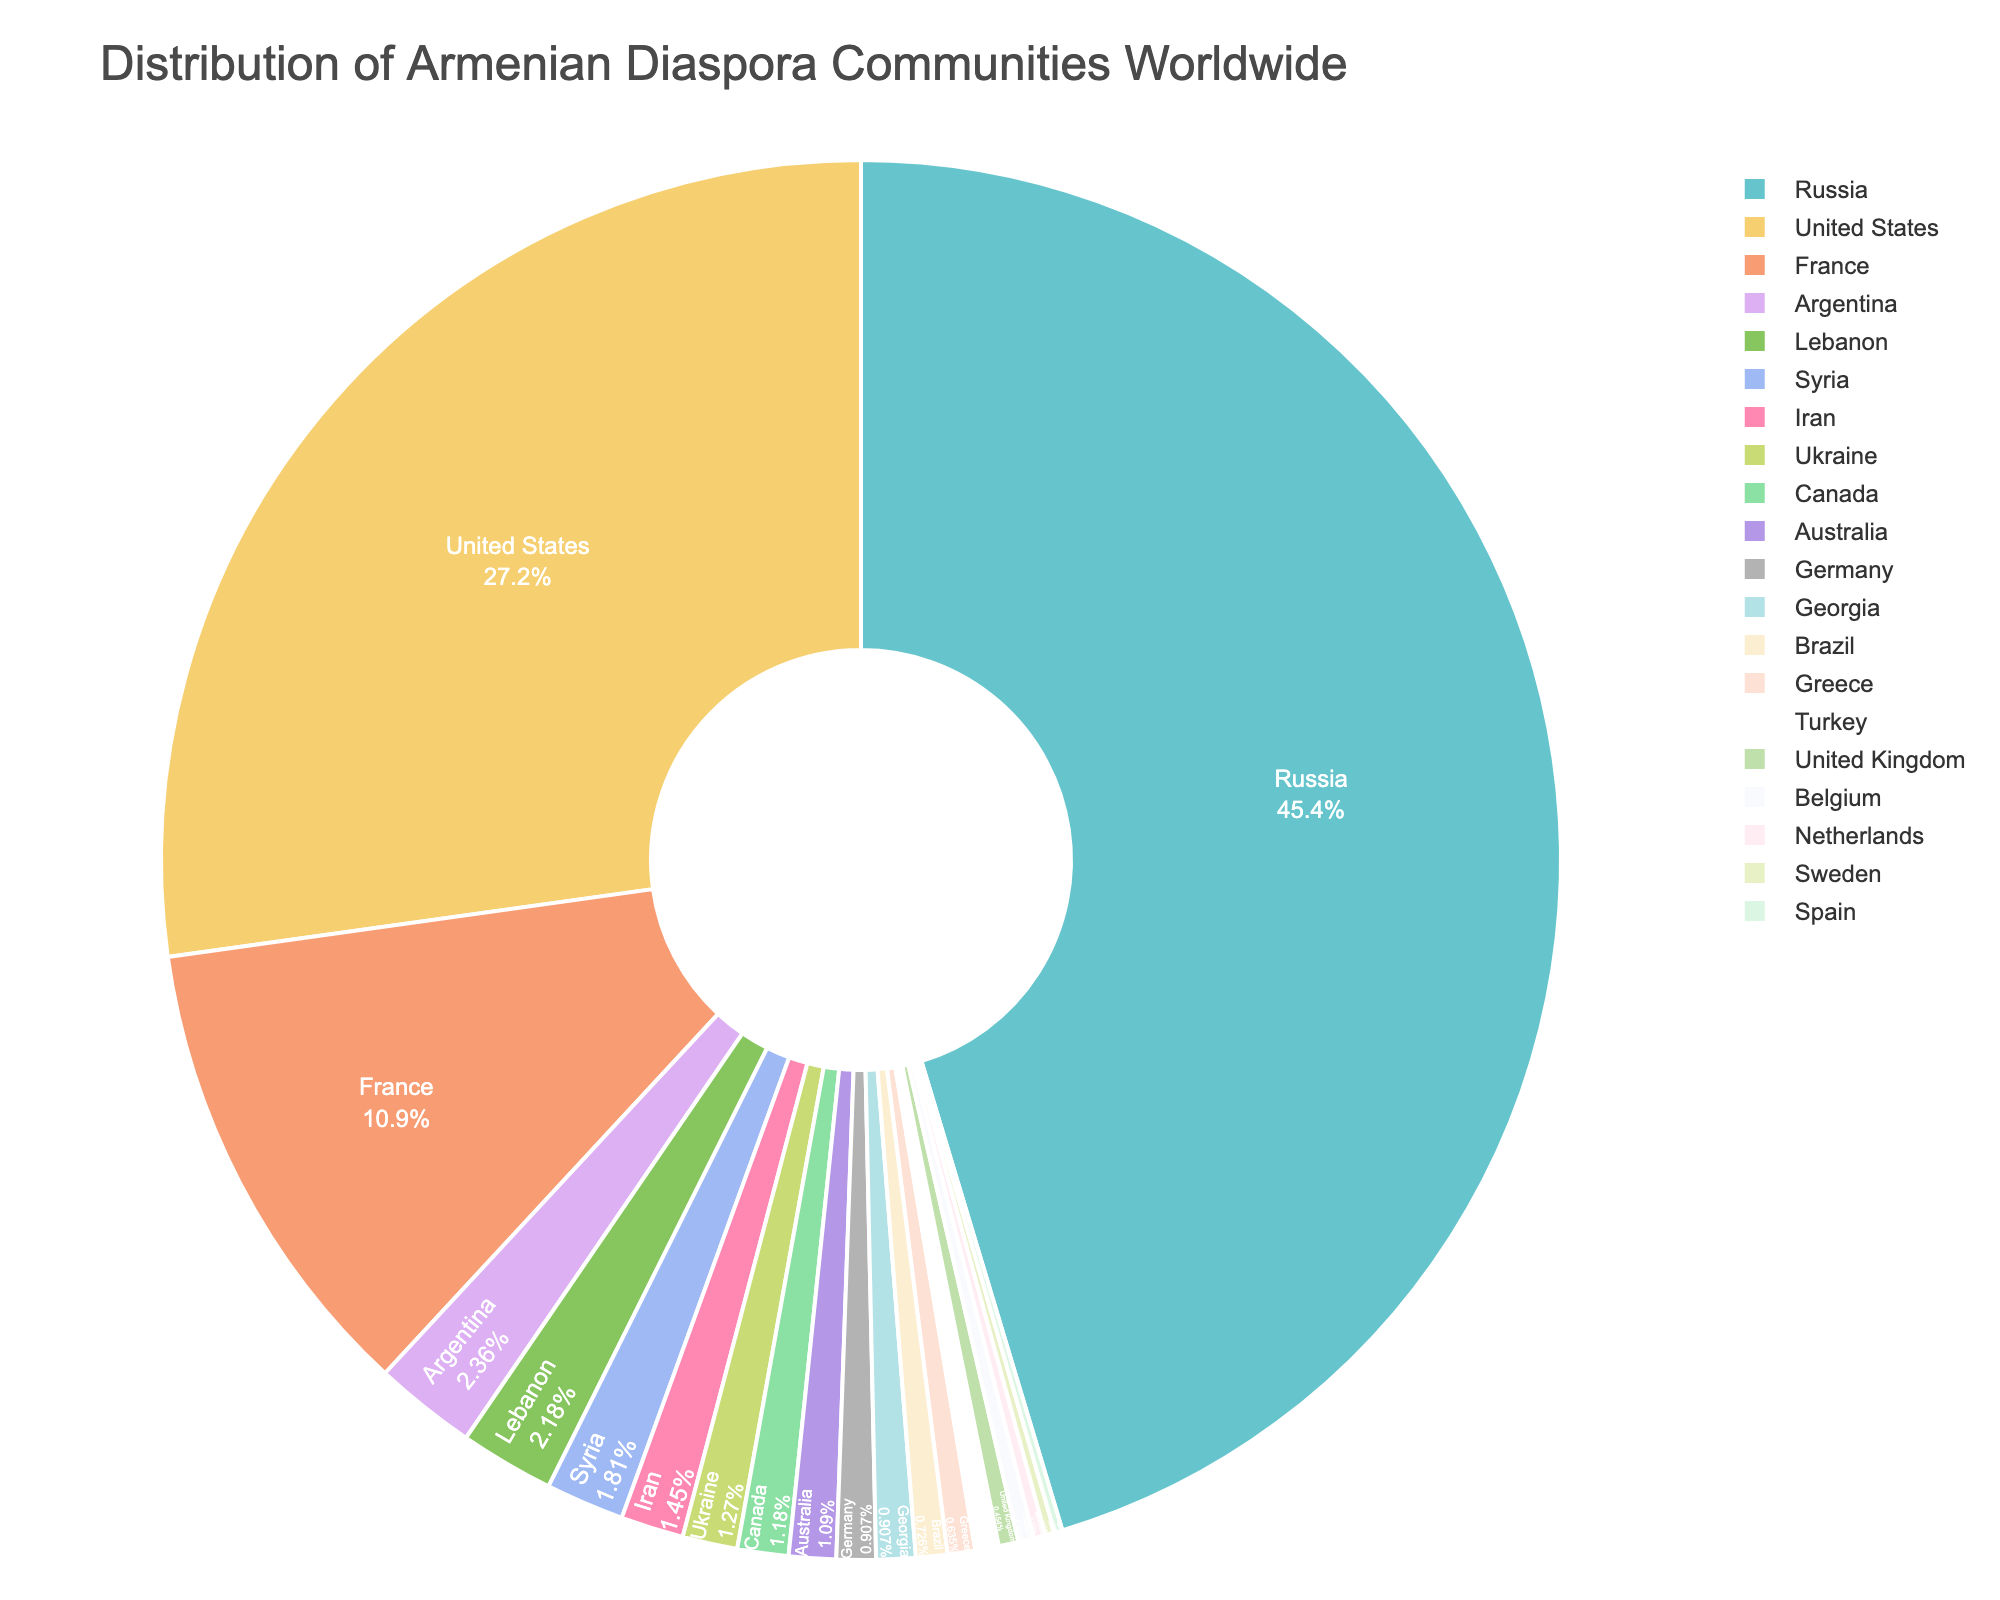Which country has the largest Armenian diaspora community? The pie chart shows the distribution of Armenian diaspora communities worldwide, with each slice representing a different country. The largest slice represents Russia, indicating it has the largest Armenian diaspora community.
Answer: Russia Out of the United States, France, and Argentina, which country has the smallest Armenian diaspora community? Comparing the slices of the United States, France, and Argentina on the pie chart, Argentina's slice is the smallest among them.
Answer: Argentina Which countries have an Armenian population that exceeds 500,000? Observing the pie chart, the countries with larger slices exceeding 500,000 Armenian populations are Russia, the United States, and France.
Answer: Russia, United States, France How does the Armenian population in Canada compare to that in Australia? By looking at the pie chart, both Canada and Australia have roughly equal-sized slices, with Canada's slice being slightly larger. Therefore, the Armenian population in Canada is slightly higher than in Australia.
Answer: Canada How many countries have an Armenian population smaller than 50,000? By counting the slices in the pie chart that are visibly smaller than the slices representing 50,000, there are six countries: Germany, Brazil, Greece, Turkey, United Kingdom, Belgium, Netherlands, Sweden, and Spain.
Answer: 8 What percentage of the total Armenian diaspora community resides in Russia? The pie chart shows Russia's slice with a text label indicating its percentage share. The percentage shown inside Russia's slice is the required answer.
Answer: 34.8% If we sum the Armenian population in Lebanon, Syria, and Iran, how does it compare to the Armenian population in France? Adding the populations from the pie chart: Lebanon (120,000), Syria (100,000), and Iran (80,000) gives 300,000. France has a population of 600,000 Armenians, so the sum (300,000) is half of France's Armenian population.
Answer: Half Which country between Georgia and Turkey has a larger Armenian population, and by what factor? Comparing the slices for Georgia and Turkey from the pie chart, Georgia has a larger Armenian population. Calculating the factor: 50,000 (Georgia) / 30,000 (Turkey) = approximately 1.67.
Answer: Georgia, by 1.67 times What is the combined percentage of Armenian populations in Russia and the United States? The pie chart shows the percentage shares of all slices. Summing the percentages for Russia and the United States provides the combined percentage.
Answer: 58% Based on the pie chart, which country has a similar Armenian population size to Greece? Observing the pie chart, Germany and Greece have similarly sized slices indicating a similar Armenian population size.
Answer: Germany 